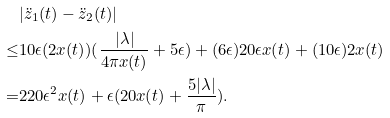<formula> <loc_0><loc_0><loc_500><loc_500>& | \ddot { z } _ { 1 } ( t ) - \ddot { z } _ { 2 } ( t ) | \\ \leq & 1 0 \epsilon ( 2 x ( t ) ) ( \frac { | \lambda | } { 4 \pi x ( t ) } + 5 \epsilon ) + ( 6 \epsilon ) 2 0 \epsilon x ( t ) + ( 1 0 \epsilon ) 2 x ( t ) \\ = & 2 2 0 \epsilon ^ { 2 } x ( t ) + \epsilon ( 2 0 x ( t ) + \frac { 5 | \lambda | } { \pi } ) .</formula> 